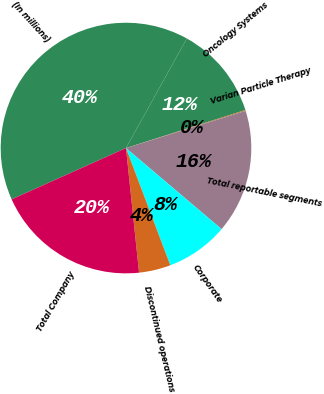Convert chart to OTSL. <chart><loc_0><loc_0><loc_500><loc_500><pie_chart><fcel>(In millions)<fcel>Oncology Systems<fcel>Varian Particle Therapy<fcel>Total reportable segments<fcel>Corporate<fcel>Discontinued operations<fcel>Total Company<nl><fcel>39.78%<fcel>12.02%<fcel>0.12%<fcel>15.99%<fcel>8.05%<fcel>4.09%<fcel>19.95%<nl></chart> 